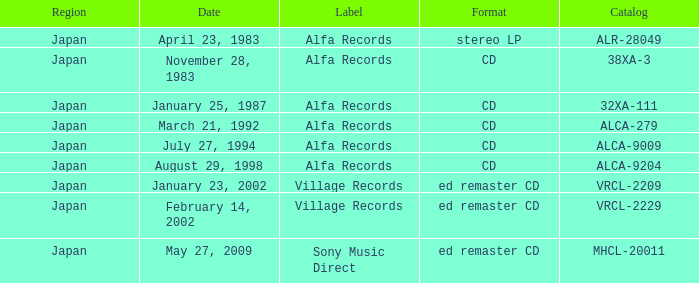Which date is in compact disc format? November 28, 1983, January 25, 1987, March 21, 1992, July 27, 1994, August 29, 1998. 